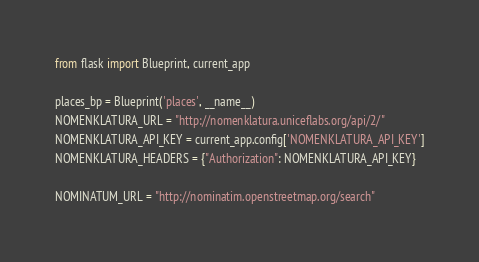<code> <loc_0><loc_0><loc_500><loc_500><_Python_>from flask import Blueprint, current_app

places_bp = Blueprint('places', __name__)
NOMENKLATURA_URL = "http://nomenklatura.uniceflabs.org/api/2/"
NOMENKLATURA_API_KEY = current_app.config['NOMENKLATURA_API_KEY']
NOMENKLATURA_HEADERS = {"Authorization": NOMENKLATURA_API_KEY}

NOMINATUM_URL = "http://nominatim.openstreetmap.org/search"
</code> 